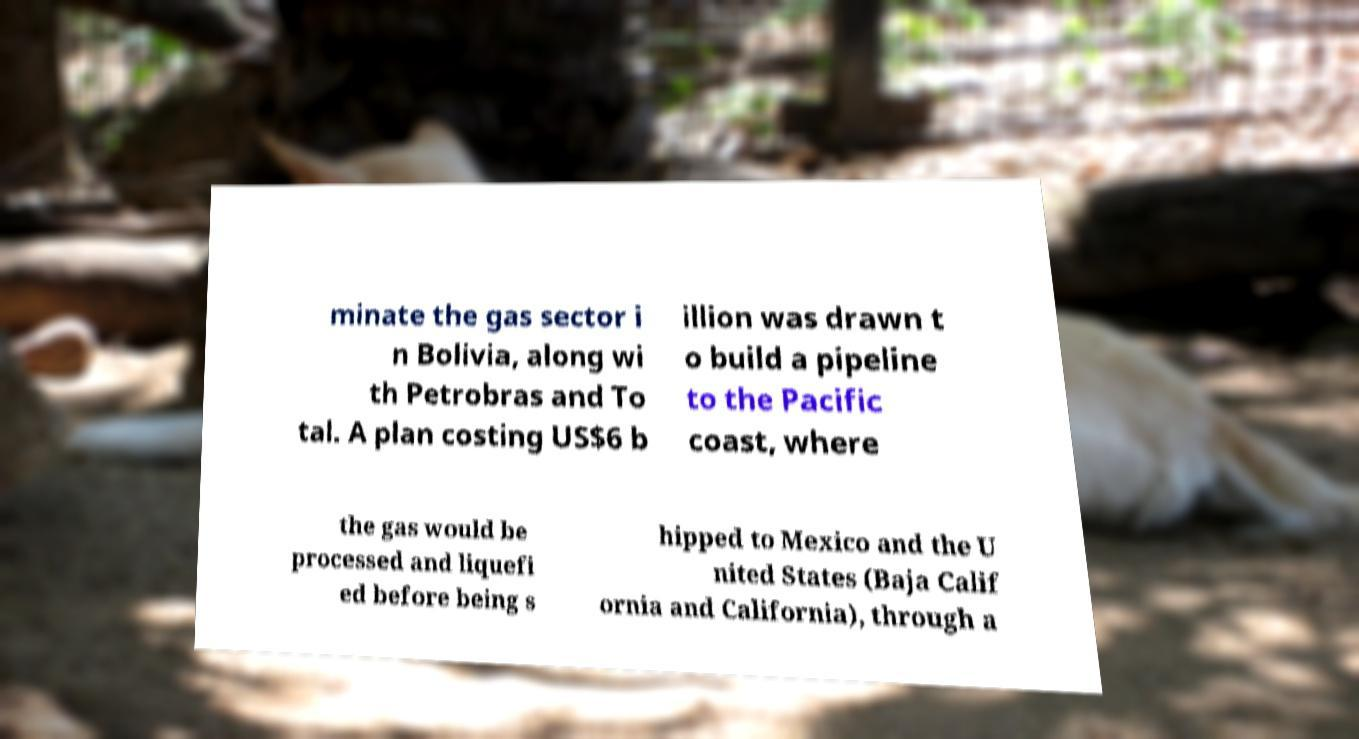Please identify and transcribe the text found in this image. minate the gas sector i n Bolivia, along wi th Petrobras and To tal. A plan costing US$6 b illion was drawn t o build a pipeline to the Pacific coast, where the gas would be processed and liquefi ed before being s hipped to Mexico and the U nited States (Baja Calif ornia and California), through a 